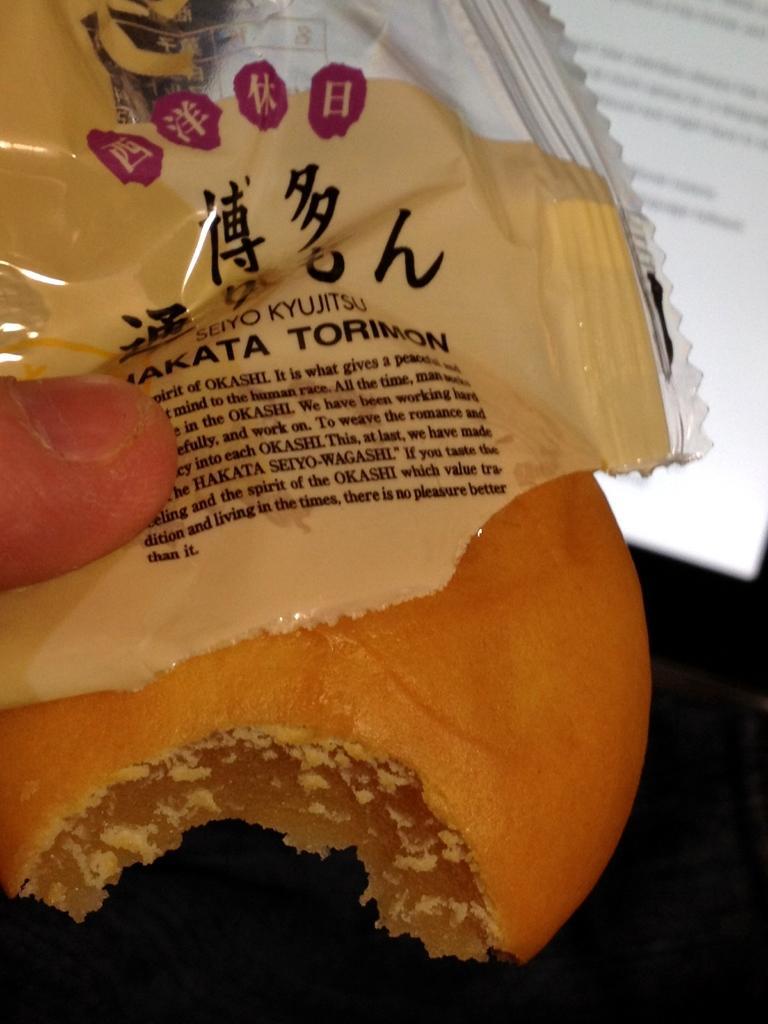Please provide a concise description of this image. In this image, we can see a food item. We can see a cover. We can see the finger of a person. We can see the screen with some text. 